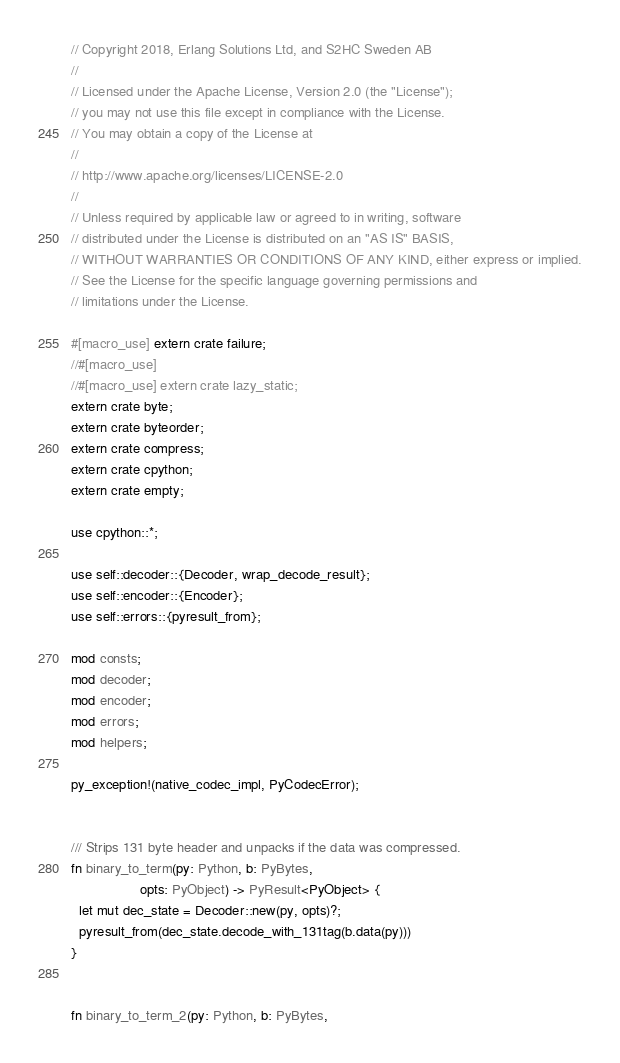<code> <loc_0><loc_0><loc_500><loc_500><_Rust_>// Copyright 2018, Erlang Solutions Ltd, and S2HC Sweden AB
//
// Licensed under the Apache License, Version 2.0 (the "License");
// you may not use this file except in compliance with the License.
// You may obtain a copy of the License at
//
// http://www.apache.org/licenses/LICENSE-2.0
//
// Unless required by applicable law or agreed to in writing, software
// distributed under the License is distributed on an "AS IS" BASIS,
// WITHOUT WARRANTIES OR CONDITIONS OF ANY KIND, either express or implied.
// See the License for the specific language governing permissions and
// limitations under the License.

#[macro_use] extern crate failure;
//#[macro_use]
//#[macro_use] extern crate lazy_static;
extern crate byte;
extern crate byteorder;
extern crate compress;
extern crate cpython;
extern crate empty;

use cpython::*;

use self::decoder::{Decoder, wrap_decode_result};
use self::encoder::{Encoder};
use self::errors::{pyresult_from};

mod consts;
mod decoder;
mod encoder;
mod errors;
mod helpers;

py_exception!(native_codec_impl, PyCodecError);


/// Strips 131 byte header and unpacks if the data was compressed.
fn binary_to_term(py: Python, b: PyBytes,
                  opts: PyObject) -> PyResult<PyObject> {
  let mut dec_state = Decoder::new(py, opts)?;
  pyresult_from(dec_state.decode_with_131tag(b.data(py)))
}


fn binary_to_term_2(py: Python, b: PyBytes,</code> 